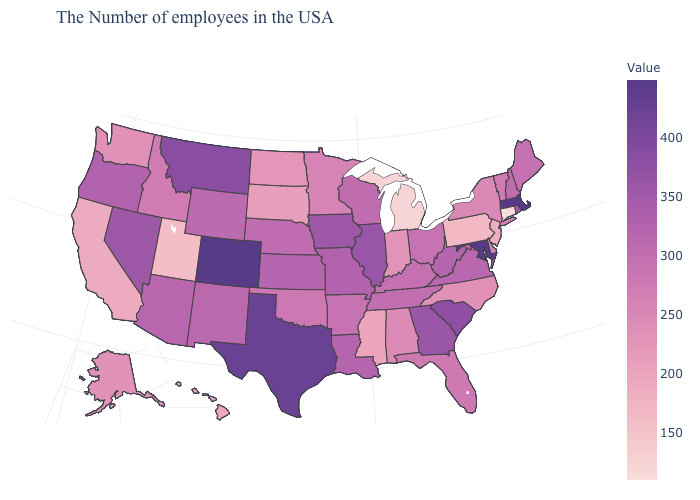Which states have the lowest value in the West?
Concise answer only. Utah. Does Connecticut have the lowest value in the USA?
Keep it brief. Yes. Which states hav the highest value in the Northeast?
Short answer required. Massachusetts. Does Oklahoma have the lowest value in the South?
Be succinct. No. Among the states that border North Carolina , which have the lowest value?
Answer briefly. Tennessee. 